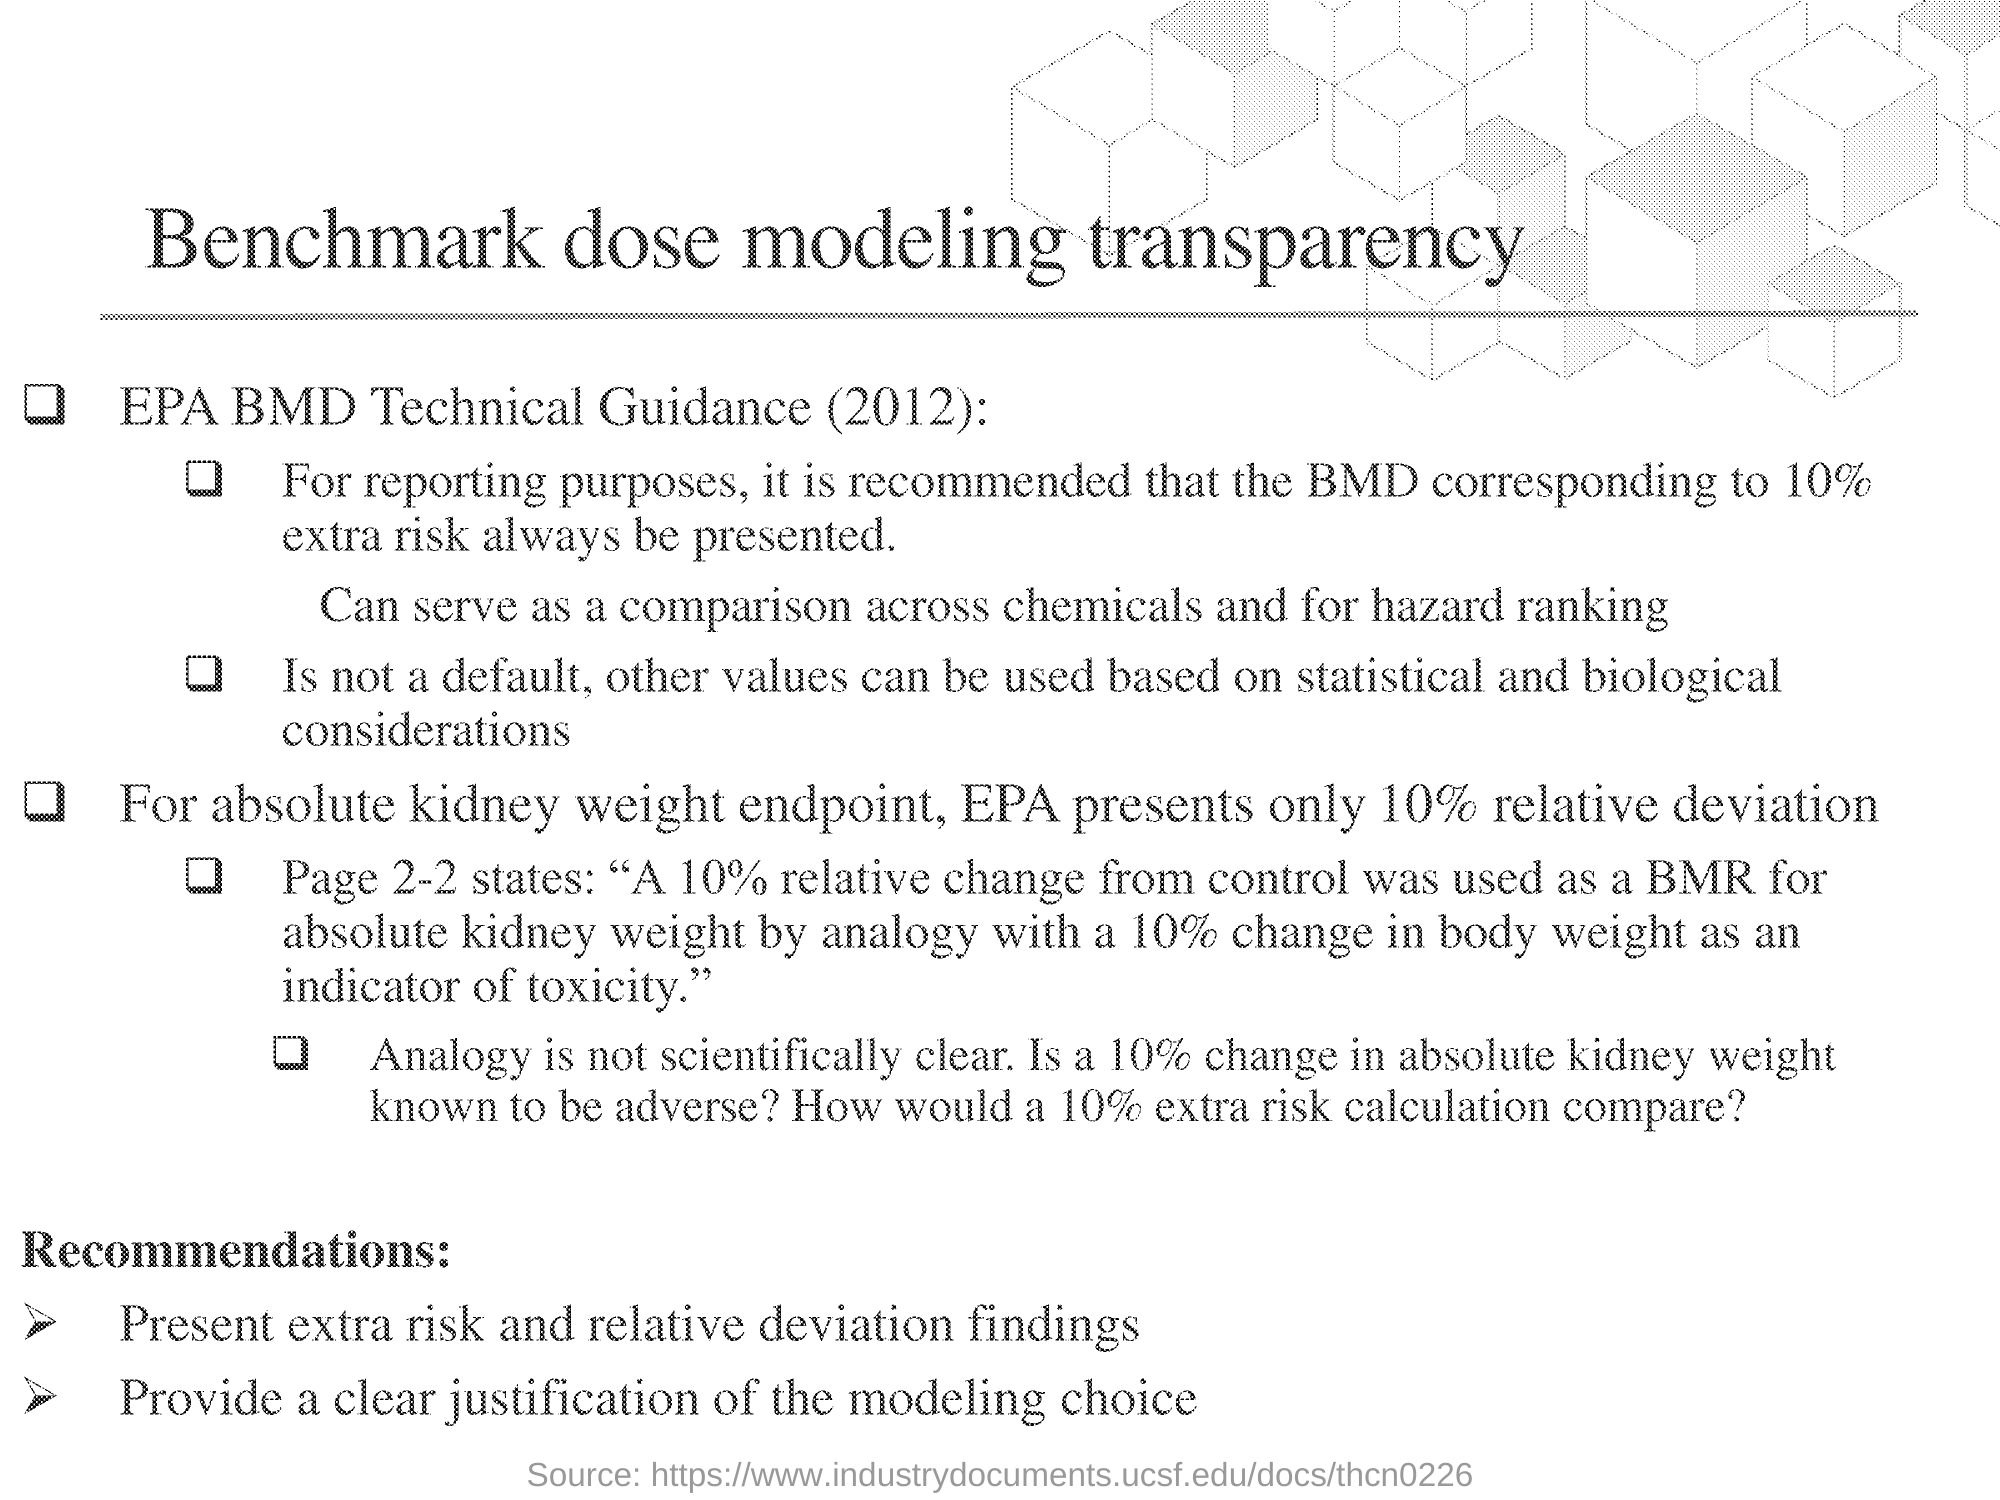What is the title of this document?
Your answer should be compact. Benchmark dose modeling transparency. What percent of relative deviation is presented by EPA for absolute kidney weight endpoint?
Provide a short and direct response. 10%. 